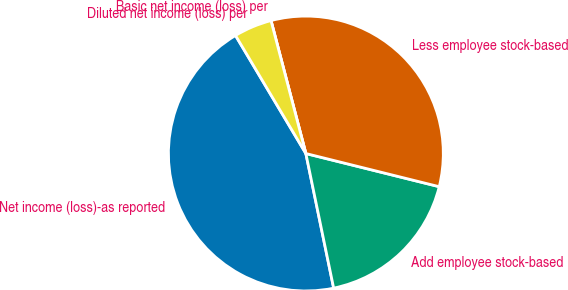<chart> <loc_0><loc_0><loc_500><loc_500><pie_chart><fcel>Net income (loss)-as reported<fcel>Add employee stock-based<fcel>Less employee stock-based<fcel>Basic net income (loss) per<fcel>Diluted net income (loss) per<nl><fcel>44.69%<fcel>17.88%<fcel>32.96%<fcel>0.0%<fcel>4.47%<nl></chart> 